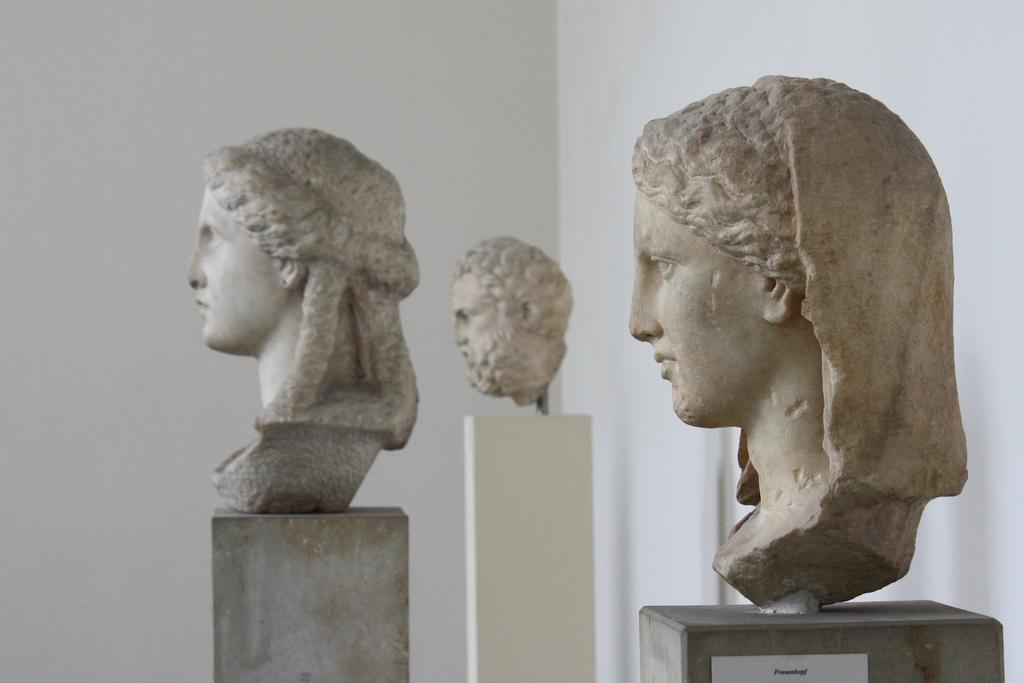What is the main subject of the image? The main subject of the image is sculptures on a stand. Can you describe the setting of the image? There is a wall in the background of the image. What type of fiction is the camera reading in the image? There is no camera or fiction present in the image; it features sculptures on a stand and a wall in the background. 